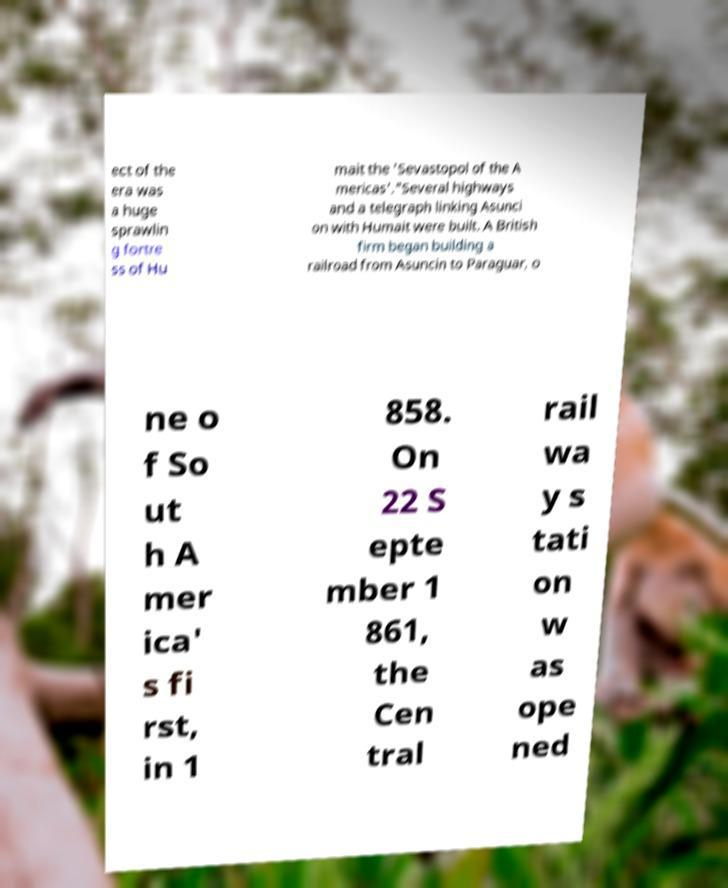For documentation purposes, I need the text within this image transcribed. Could you provide that? ect of the era was a huge sprawlin g fortre ss of Hu mait the 'Sevastopol of the A mericas'."Several highways and a telegraph linking Asunci on with Humait were built. A British firm began building a railroad from Asuncin to Paraguar, o ne o f So ut h A mer ica' s fi rst, in 1 858. On 22 S epte mber 1 861, the Cen tral rail wa y s tati on w as ope ned 